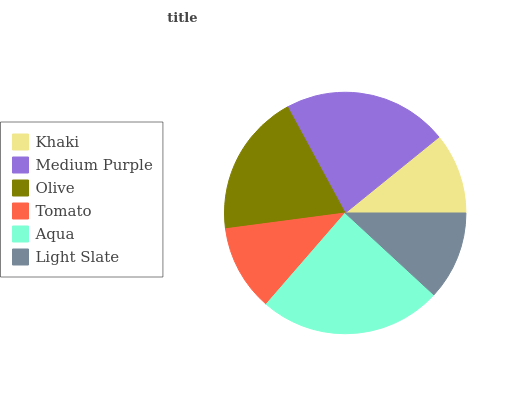Is Khaki the minimum?
Answer yes or no. Yes. Is Aqua the maximum?
Answer yes or no. Yes. Is Medium Purple the minimum?
Answer yes or no. No. Is Medium Purple the maximum?
Answer yes or no. No. Is Medium Purple greater than Khaki?
Answer yes or no. Yes. Is Khaki less than Medium Purple?
Answer yes or no. Yes. Is Khaki greater than Medium Purple?
Answer yes or no. No. Is Medium Purple less than Khaki?
Answer yes or no. No. Is Olive the high median?
Answer yes or no. Yes. Is Light Slate the low median?
Answer yes or no. Yes. Is Khaki the high median?
Answer yes or no. No. Is Tomato the low median?
Answer yes or no. No. 